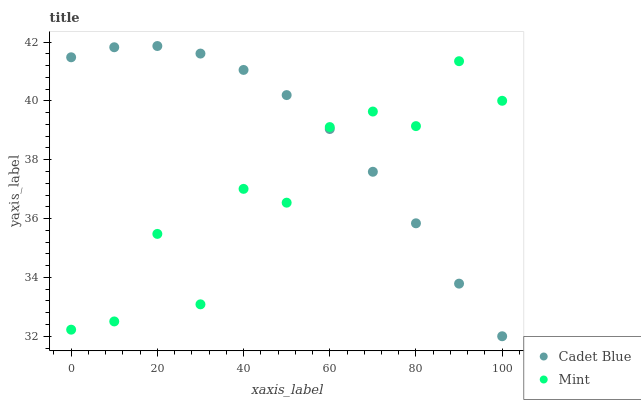Does Mint have the minimum area under the curve?
Answer yes or no. Yes. Does Cadet Blue have the maximum area under the curve?
Answer yes or no. Yes. Does Mint have the maximum area under the curve?
Answer yes or no. No. Is Cadet Blue the smoothest?
Answer yes or no. Yes. Is Mint the roughest?
Answer yes or no. Yes. Is Mint the smoothest?
Answer yes or no. No. Does Cadet Blue have the lowest value?
Answer yes or no. Yes. Does Mint have the lowest value?
Answer yes or no. No. Does Cadet Blue have the highest value?
Answer yes or no. Yes. Does Mint have the highest value?
Answer yes or no. No. Does Cadet Blue intersect Mint?
Answer yes or no. Yes. Is Cadet Blue less than Mint?
Answer yes or no. No. Is Cadet Blue greater than Mint?
Answer yes or no. No. 